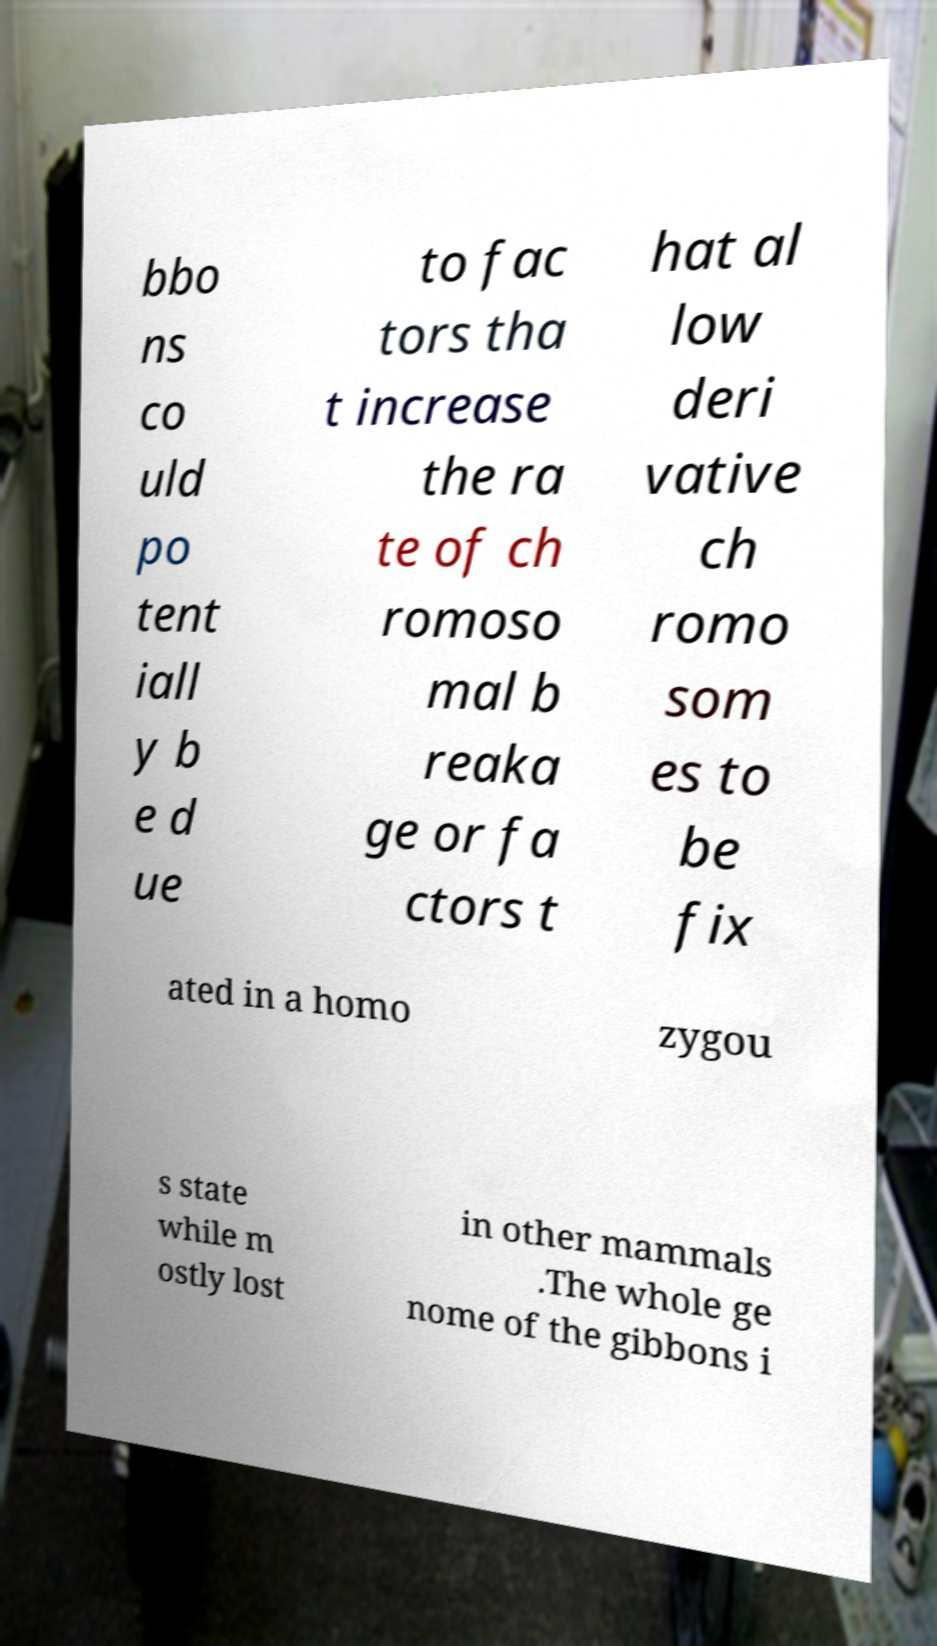Can you accurately transcribe the text from the provided image for me? bbo ns co uld po tent iall y b e d ue to fac tors tha t increase the ra te of ch romoso mal b reaka ge or fa ctors t hat al low deri vative ch romo som es to be fix ated in a homo zygou s state while m ostly lost in other mammals .The whole ge nome of the gibbons i 